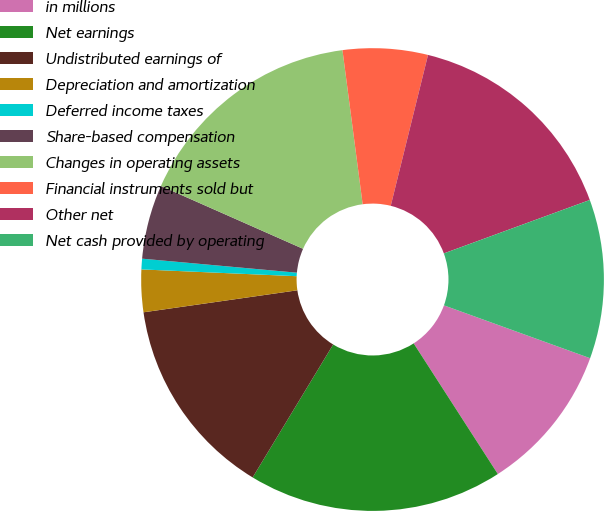Convert chart to OTSL. <chart><loc_0><loc_0><loc_500><loc_500><pie_chart><fcel>in millions<fcel>Net earnings<fcel>Undistributed earnings of<fcel>Depreciation and amortization<fcel>Deferred income taxes<fcel>Share-based compensation<fcel>Changes in operating assets<fcel>Financial instruments sold but<fcel>Other net<fcel>Net cash provided by operating<nl><fcel>10.37%<fcel>17.78%<fcel>14.07%<fcel>2.96%<fcel>0.74%<fcel>5.19%<fcel>16.3%<fcel>5.93%<fcel>15.56%<fcel>11.11%<nl></chart> 